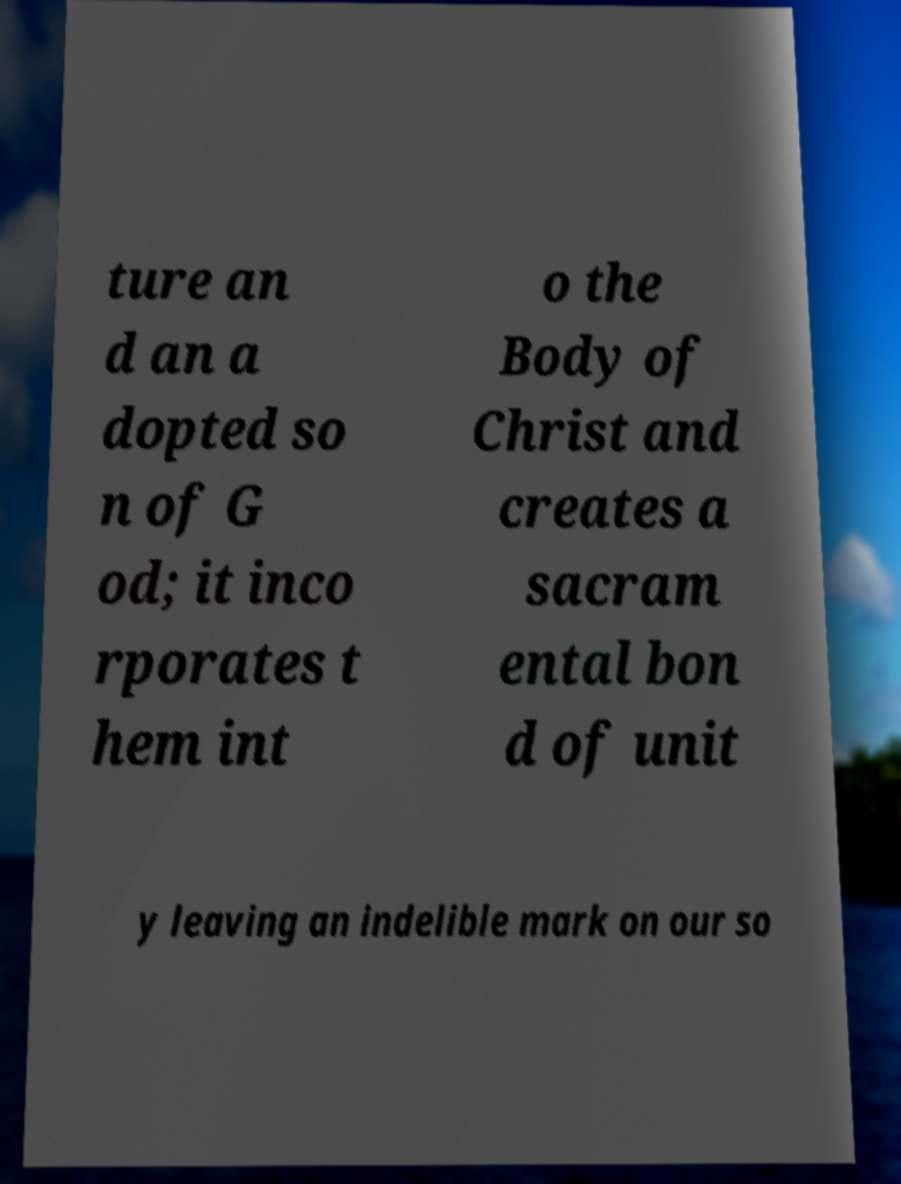Could you assist in decoding the text presented in this image and type it out clearly? ture an d an a dopted so n of G od; it inco rporates t hem int o the Body of Christ and creates a sacram ental bon d of unit y leaving an indelible mark on our so 